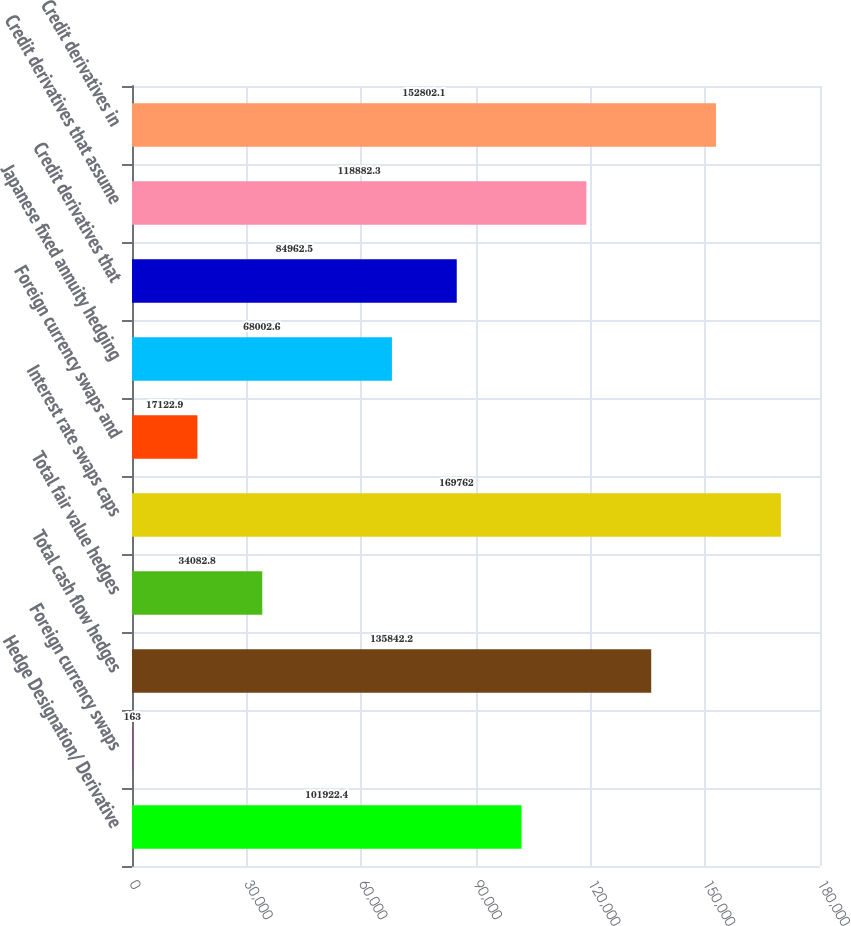Convert chart. <chart><loc_0><loc_0><loc_500><loc_500><bar_chart><fcel>Hedge Designation/ Derivative<fcel>Foreign currency swaps<fcel>Total cash flow hedges<fcel>Total fair value hedges<fcel>Interest rate swaps caps<fcel>Foreign currency swaps and<fcel>Japanese fixed annuity hedging<fcel>Credit derivatives that<fcel>Credit derivatives that assume<fcel>Credit derivatives in<nl><fcel>101922<fcel>163<fcel>135842<fcel>34082.8<fcel>169762<fcel>17122.9<fcel>68002.6<fcel>84962.5<fcel>118882<fcel>152802<nl></chart> 